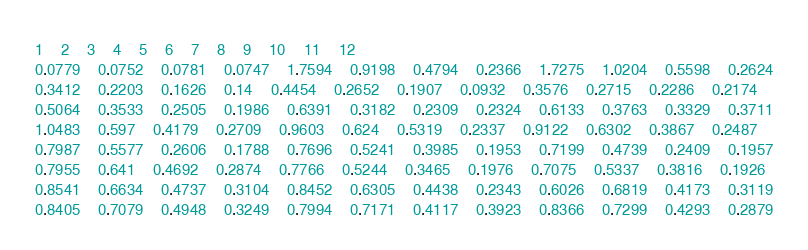<code> <loc_0><loc_0><loc_500><loc_500><_SQL_>1	2	3	4	5	6	7	8	9	10	11	12
0.0779	0.0752	0.0781	0.0747	1.7594	0.9198	0.4794	0.2366	1.7275	1.0204	0.5598	0.2624
0.3412	0.2203	0.1626	0.14	0.4454	0.2652	0.1907	0.0932	0.3576	0.2715	0.2286	0.2174
0.5064	0.3533	0.2505	0.1986	0.6391	0.3182	0.2309	0.2324	0.6133	0.3763	0.3329	0.3711
1.0483	0.597	0.4179	0.2709	0.9603	0.624	0.5319	0.2337	0.9122	0.6302	0.3867	0.2487
0.7987	0.5577	0.2606	0.1788	0.7696	0.5241	0.3985	0.1953	0.7199	0.4739	0.2409	0.1957
0.7955	0.641	0.4692	0.2874	0.7766	0.5244	0.3465	0.1976	0.7075	0.5337	0.3816	0.1926
0.8541	0.6634	0.4737	0.3104	0.8452	0.6305	0.4438	0.2343	0.6026	0.6819	0.4173	0.3119
0.8405	0.7079	0.4948	0.3249	0.7994	0.7171	0.4117	0.3923	0.8366	0.7299	0.4293	0.2879
</code> 